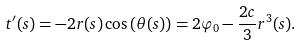Convert formula to latex. <formula><loc_0><loc_0><loc_500><loc_500>t ^ { \prime } ( s ) = - 2 r ( s ) \cos { \left ( \theta ( s ) \right ) } = 2 \varphi _ { 0 } - \frac { 2 c } { 3 } r ^ { 3 } ( s ) .</formula> 